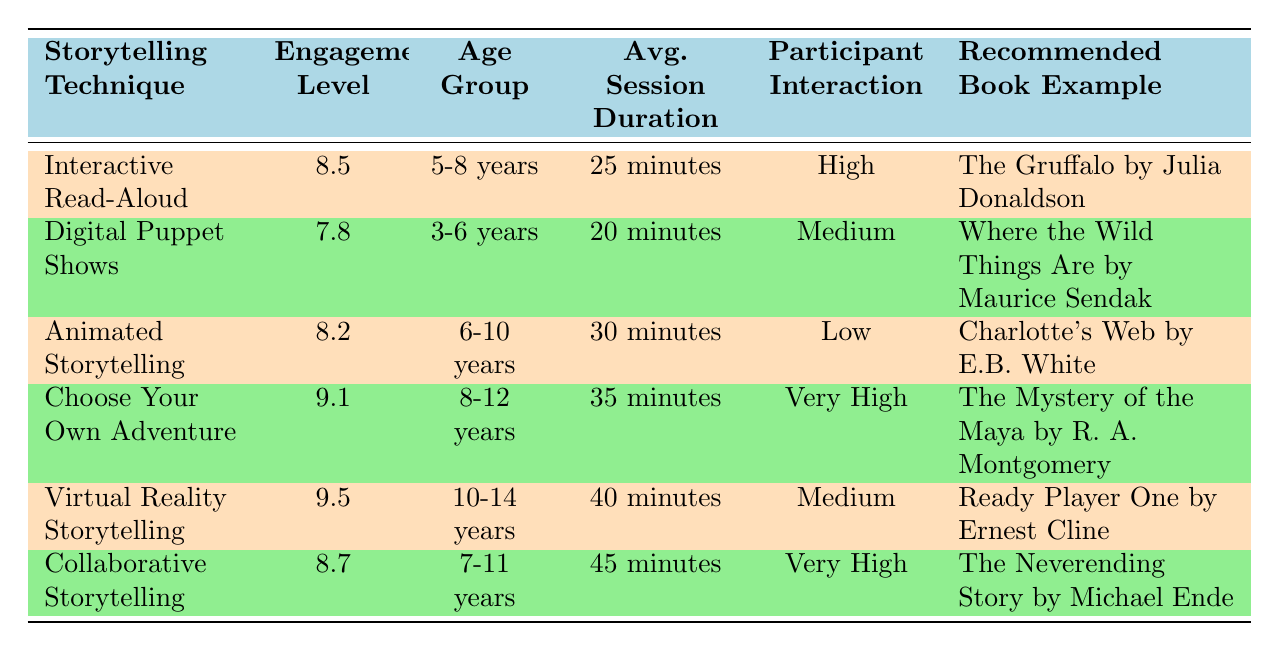What is the engagement level of Interactive Read-Aloud? From the table, the engagement level for Interactive Read-Aloud is listed directly as 8.5.
Answer: 8.5 Which storytelling technique has the highest engagement level? By examining the engagement levels in the table, Virtual Reality Storytelling has the highest level at 9.5.
Answer: 9.5 What are the average session durations for age groups 6-10 years and 8-12 years? The session duration for Animated Storytelling (6-10 years) is 30 minutes, and for Choose Your Own Adventure (8-12 years), it is 35 minutes. Adding these, the total is 30 + 35 = 65 minutes, and dividing by 2 gives the average of 32.5 minutes.
Answer: 32.5 minutes Is the participant interaction level for Collaborative Storytelling categorized as high? Looking at the table, Collaborative Storytelling has a participant interaction level categorized as Very High, not High. Thus, the answer is false.
Answer: No Which technique is recommended for ages 3-6 years and what is its engagement level? The table shows that Digital Puppet Shows is recommended for ages 3-6 years, with an engagement level of 7.8.
Answer: Digital Puppet Shows, 7.8 What is the difference in engagement levels between Choose Your Own Adventure and Animated Storytelling? Choose Your Own Adventure engagement level is 9.1, and Animated Storytelling is 8.2. Calculating the difference: 9.1 - 8.2 = 0.9.
Answer: 0.9 What storytelling technique has the lowest average session duration and what is its value? Digital Puppet Shows has the lowest average session duration at 20 minutes, as observed in the table.
Answer: 20 minutes Are all storytelling techniques intended for the same age group? A quick look at the table reveals that each technique is targeted at different age groups, so the answer is false.
Answer: No What is the average engagement level across all techniques listed? To find the average, sum the engagement levels (8.5 + 7.8 + 8.2 + 9.1 + 9.5 + 8.7 = 51.8) and divide by the number of techniques (6): 51.8/6 = approximately 8.63.
Answer: 8.63 